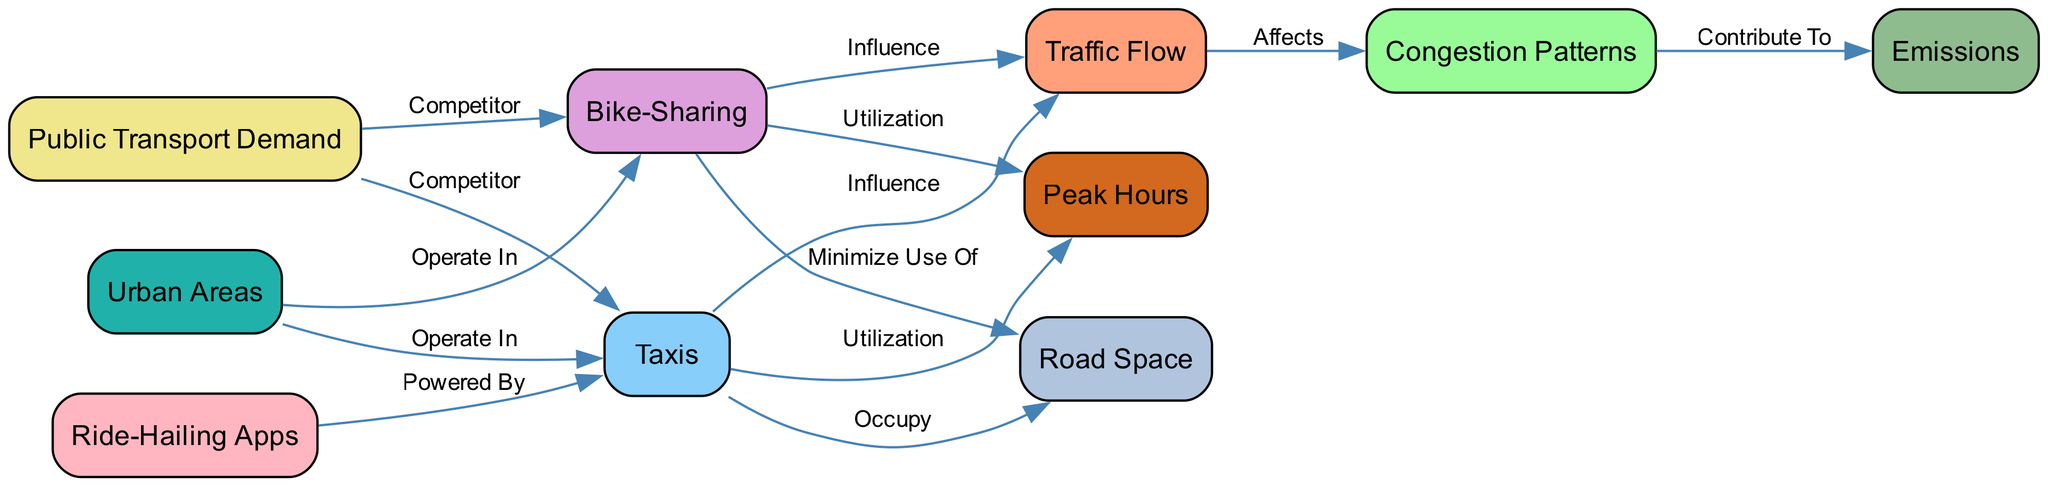What is one of the nodes that taxi systems contribute to in urban areas? The diagram shows that taxis influence traffic flow. Hence, their contribution is specifically directed towards the traffic flow node.
Answer: Traffic Flow How do bike-sharing systems affect road space use? According to the diagram, bike-sharing systems minimize the use of road space, indicating that they take up less room compared to taxis.
Answer: Minimize Use Of How many nodes are there in the diagram? By counting the nodes in the provided data, we find a total of ten nodes listed.
Answer: 10 What pattern does traffic flow affect according to the diagram? The diagram indicates that traffic flow affects congestion patterns, establishing a direct relationship between the two concepts.
Answer: Congestion Patterns What role do ride-hailing apps play concerning taxis? The diagram specifies that ride-hailing apps power taxis, illustrating a significant connection between these two nodes in the context of urban transport.
Answer: Powered By Which two systems are indicated as competitors in public transport demand? The diagram shows that both taxis and bike-sharing systems are positioned as competitors in the public transport demand node.
Answer: Taxis and Bike-Sharing What is a consequence of congestion patterns as depicted in the diagram? The diagram shows that congestion patterns contribute to emissions, indicating a negative environmental impact arising from traffic congestion.
Answer: Emissions At what time do taxis show high utilization according to the diagram? The diagram specifies that taxis are utilized during peak hours, suggesting that demand for taxi services increases at this time.
Answer: Peak Hours Which system is indicated to occupy more road space? The diagram shows that taxis occupy road space, whereas bike-sharing systems are designed to minimize this usage, leading to a difference in their impact on road utilization.
Answer: Taxis Which node is associated with the operation of both taxis and bike-sharing systems? The urban areas node is associated with both taxis and bike-sharing systems, indicating that they both operate within the same geographic context.
Answer: Urban Areas 